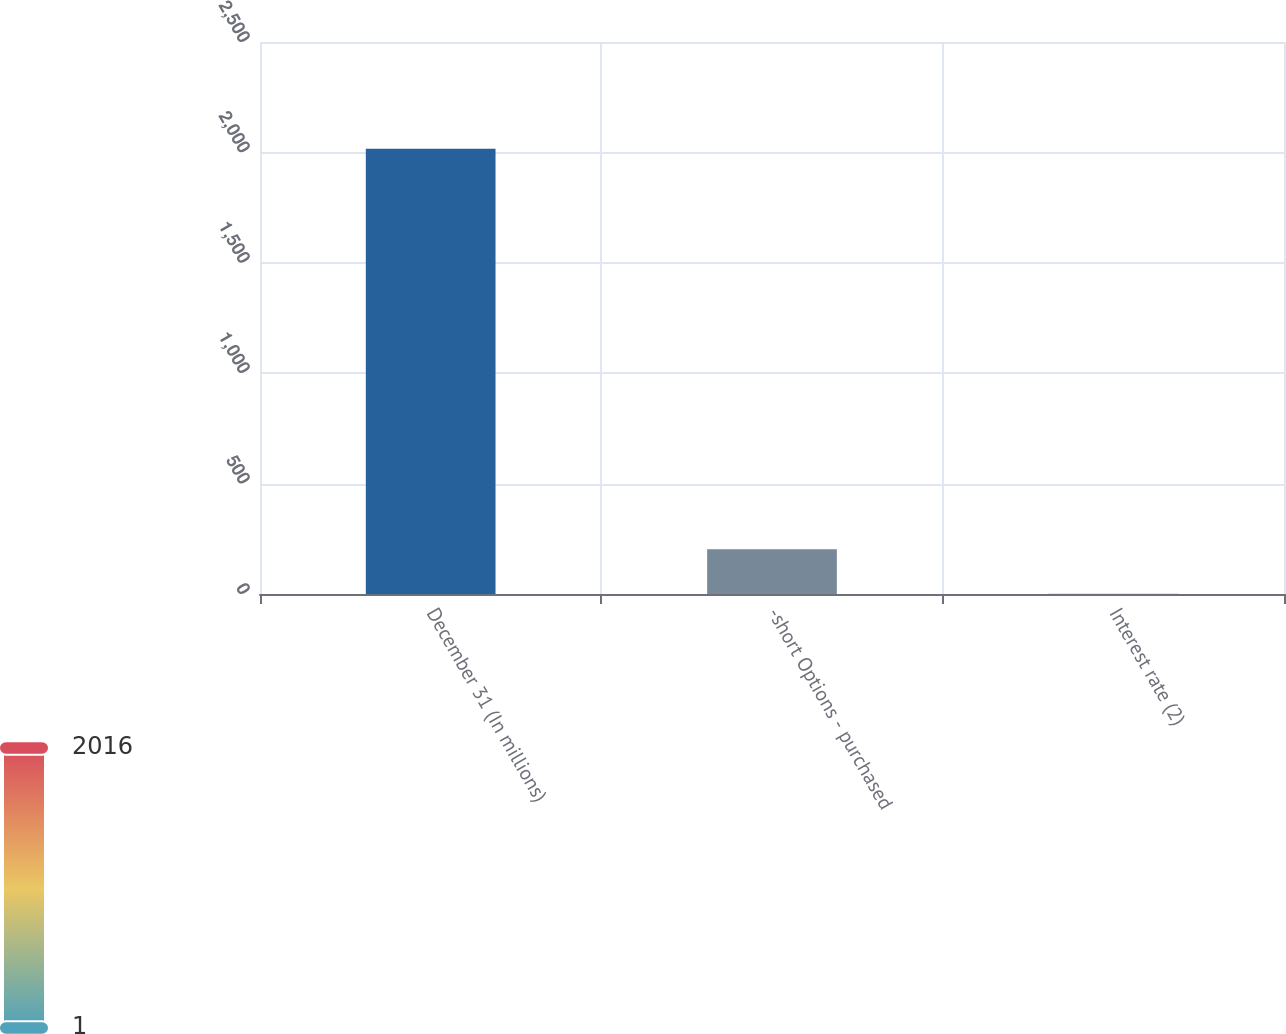<chart> <loc_0><loc_0><loc_500><loc_500><bar_chart><fcel>December 31 (In millions)<fcel>-short Options - purchased<fcel>Interest rate (2)<nl><fcel>2016<fcel>202.5<fcel>1<nl></chart> 